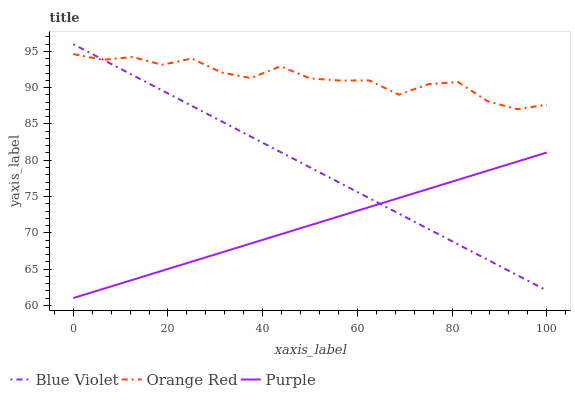Does Purple have the minimum area under the curve?
Answer yes or no. Yes. Does Orange Red have the maximum area under the curve?
Answer yes or no. Yes. Does Blue Violet have the minimum area under the curve?
Answer yes or no. No. Does Blue Violet have the maximum area under the curve?
Answer yes or no. No. Is Blue Violet the smoothest?
Answer yes or no. Yes. Is Orange Red the roughest?
Answer yes or no. Yes. Is Orange Red the smoothest?
Answer yes or no. No. Is Blue Violet the roughest?
Answer yes or no. No. Does Blue Violet have the lowest value?
Answer yes or no. No. Does Orange Red have the highest value?
Answer yes or no. No. Is Purple less than Orange Red?
Answer yes or no. Yes. Is Orange Red greater than Purple?
Answer yes or no. Yes. Does Purple intersect Orange Red?
Answer yes or no. No. 